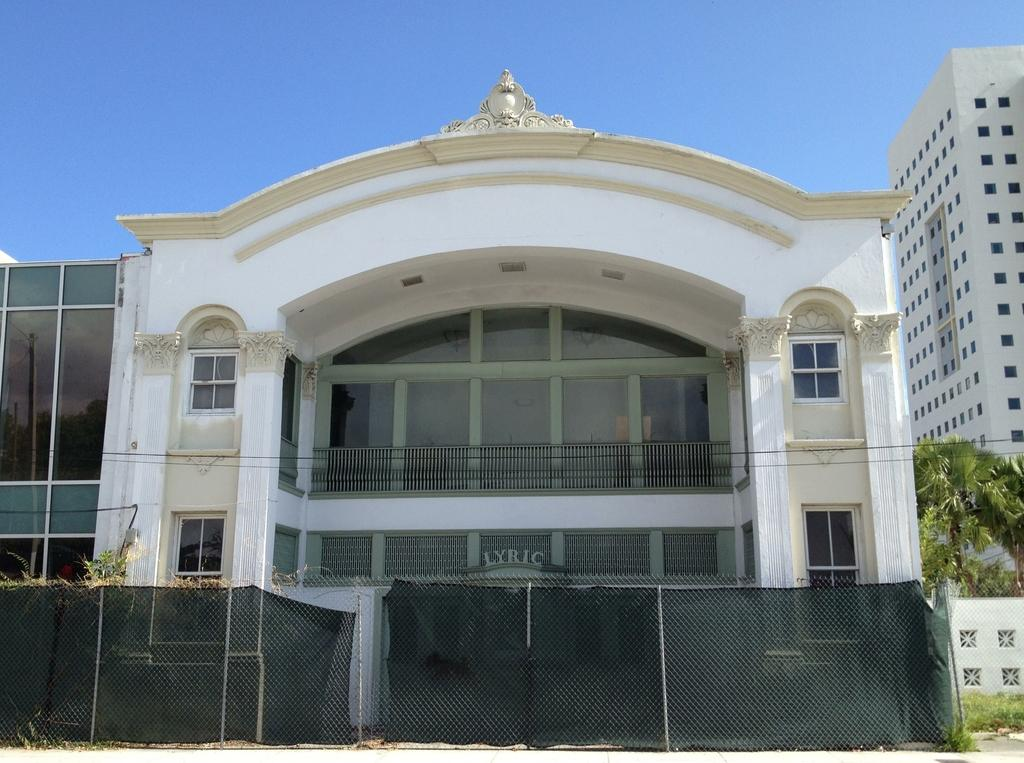What can be seen in the foreground of the picture? In the foreground of the picture, there are trees, fencing, plants, a road, and a wall. What type of structures are visible in the middle of the picture? There are buildings in the middle of the picture. What is visible at the top of the picture? The sky is visible at the top of the picture. What type of arithmetic problem is being solved on the wall in the picture? There is no arithmetic problem visible on the wall in the picture. What type of stew is being cooked in the trees in the foreground of the picture? There is no stew being cooked in the trees in the foreground of the picture. 